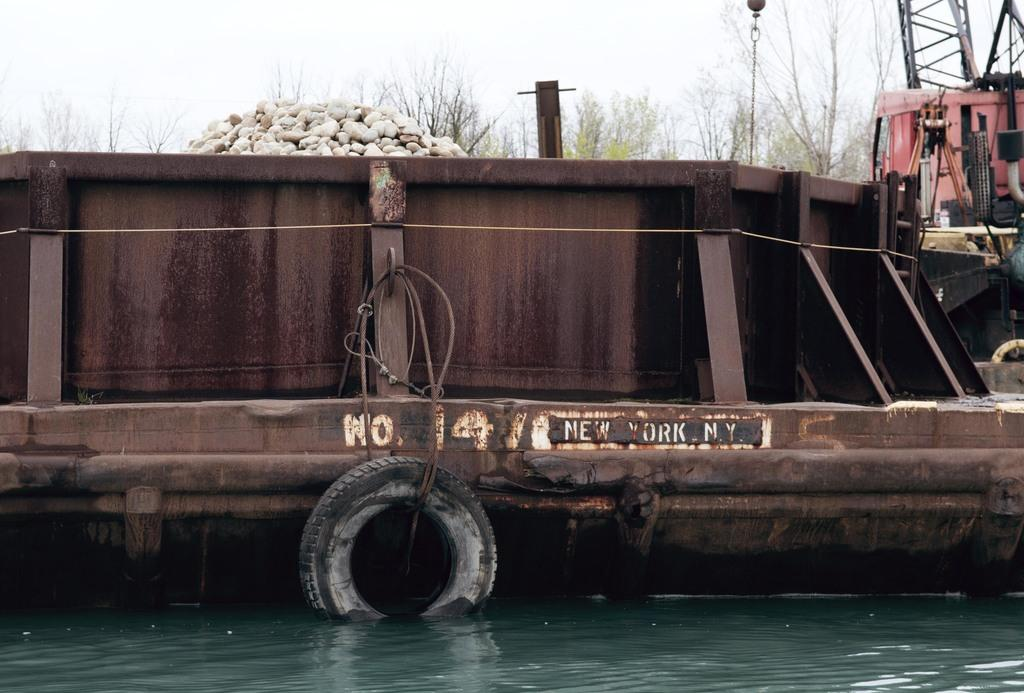What type of boat is in the image? There is an old pump boat in the image. Where is the pump boat located? The pump boat is on a river. What other natural elements can be seen in the image? There are rocks and trees visible in the image. What is visible in the background of the image? The sky is visible in the image. What type of yard can be seen in the image? There is no yard present in the image; it features an old pump boat on a river with rocks, trees, and a visible sky. 